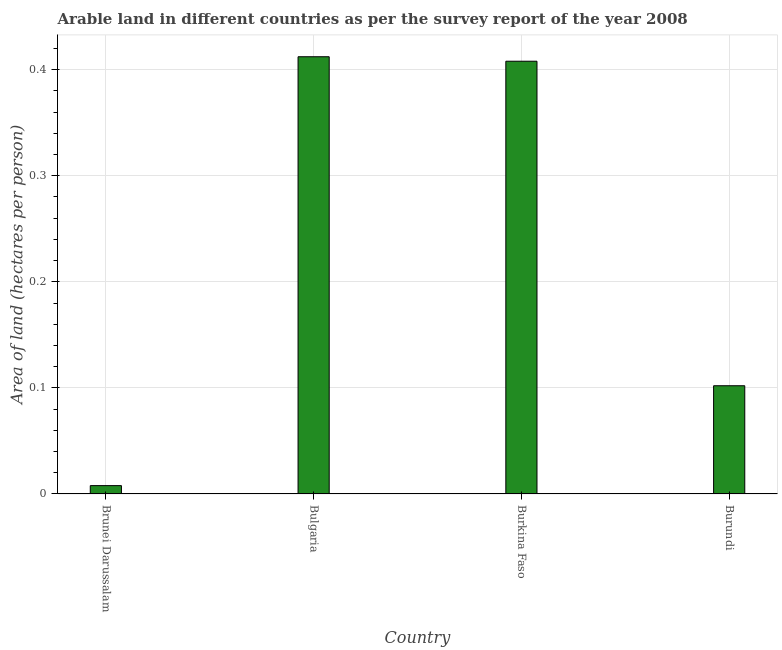Does the graph contain grids?
Offer a very short reply. Yes. What is the title of the graph?
Keep it short and to the point. Arable land in different countries as per the survey report of the year 2008. What is the label or title of the X-axis?
Give a very brief answer. Country. What is the label or title of the Y-axis?
Give a very brief answer. Area of land (hectares per person). What is the area of arable land in Brunei Darussalam?
Make the answer very short. 0.01. Across all countries, what is the maximum area of arable land?
Your response must be concise. 0.41. Across all countries, what is the minimum area of arable land?
Your answer should be very brief. 0.01. In which country was the area of arable land maximum?
Give a very brief answer. Bulgaria. In which country was the area of arable land minimum?
Keep it short and to the point. Brunei Darussalam. What is the sum of the area of arable land?
Keep it short and to the point. 0.93. What is the difference between the area of arable land in Brunei Darussalam and Burkina Faso?
Give a very brief answer. -0.4. What is the average area of arable land per country?
Make the answer very short. 0.23. What is the median area of arable land?
Make the answer very short. 0.25. In how many countries, is the area of arable land greater than 0.34 hectares per person?
Make the answer very short. 2. What is the ratio of the area of arable land in Brunei Darussalam to that in Burundi?
Offer a very short reply. 0.08. Is the area of arable land in Burkina Faso less than that in Burundi?
Make the answer very short. No. Is the difference between the area of arable land in Brunei Darussalam and Burundi greater than the difference between any two countries?
Offer a very short reply. No. What is the difference between the highest and the second highest area of arable land?
Offer a terse response. 0. In how many countries, is the area of arable land greater than the average area of arable land taken over all countries?
Ensure brevity in your answer.  2. How many bars are there?
Your response must be concise. 4. Are the values on the major ticks of Y-axis written in scientific E-notation?
Offer a very short reply. No. What is the Area of land (hectares per person) of Brunei Darussalam?
Your answer should be very brief. 0.01. What is the Area of land (hectares per person) in Bulgaria?
Your answer should be compact. 0.41. What is the Area of land (hectares per person) in Burkina Faso?
Offer a very short reply. 0.41. What is the Area of land (hectares per person) in Burundi?
Offer a terse response. 0.1. What is the difference between the Area of land (hectares per person) in Brunei Darussalam and Bulgaria?
Keep it short and to the point. -0.4. What is the difference between the Area of land (hectares per person) in Brunei Darussalam and Burkina Faso?
Provide a succinct answer. -0.4. What is the difference between the Area of land (hectares per person) in Brunei Darussalam and Burundi?
Offer a terse response. -0.09. What is the difference between the Area of land (hectares per person) in Bulgaria and Burkina Faso?
Ensure brevity in your answer.  0. What is the difference between the Area of land (hectares per person) in Bulgaria and Burundi?
Your response must be concise. 0.31. What is the difference between the Area of land (hectares per person) in Burkina Faso and Burundi?
Offer a very short reply. 0.31. What is the ratio of the Area of land (hectares per person) in Brunei Darussalam to that in Bulgaria?
Your answer should be very brief. 0.02. What is the ratio of the Area of land (hectares per person) in Brunei Darussalam to that in Burkina Faso?
Your response must be concise. 0.02. What is the ratio of the Area of land (hectares per person) in Brunei Darussalam to that in Burundi?
Offer a very short reply. 0.08. What is the ratio of the Area of land (hectares per person) in Bulgaria to that in Burundi?
Provide a short and direct response. 4.04. What is the ratio of the Area of land (hectares per person) in Burkina Faso to that in Burundi?
Give a very brief answer. 4. 